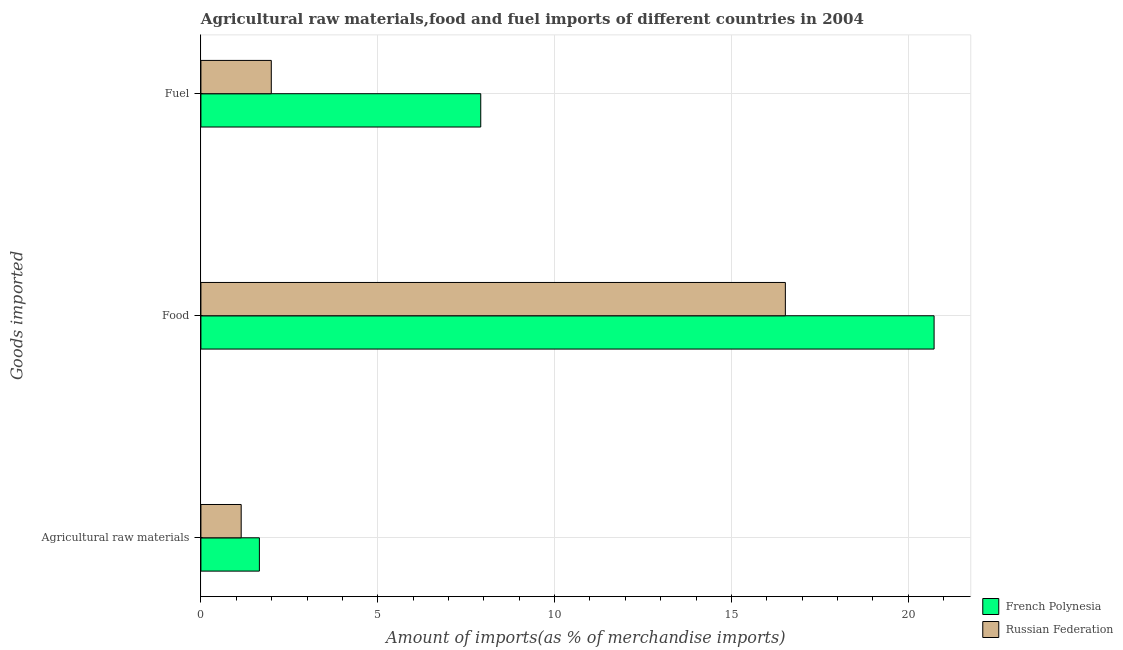How many groups of bars are there?
Provide a short and direct response. 3. Are the number of bars on each tick of the Y-axis equal?
Your response must be concise. Yes. How many bars are there on the 3rd tick from the top?
Provide a short and direct response. 2. What is the label of the 3rd group of bars from the top?
Your answer should be very brief. Agricultural raw materials. What is the percentage of fuel imports in French Polynesia?
Provide a short and direct response. 7.91. Across all countries, what is the maximum percentage of raw materials imports?
Offer a terse response. 1.65. Across all countries, what is the minimum percentage of fuel imports?
Your answer should be compact. 1.99. In which country was the percentage of food imports maximum?
Ensure brevity in your answer.  French Polynesia. In which country was the percentage of raw materials imports minimum?
Ensure brevity in your answer.  Russian Federation. What is the total percentage of food imports in the graph?
Give a very brief answer. 37.25. What is the difference between the percentage of fuel imports in French Polynesia and that in Russian Federation?
Make the answer very short. 5.92. What is the difference between the percentage of fuel imports in French Polynesia and the percentage of raw materials imports in Russian Federation?
Give a very brief answer. 6.77. What is the average percentage of food imports per country?
Your answer should be compact. 18.63. What is the difference between the percentage of food imports and percentage of fuel imports in French Polynesia?
Offer a very short reply. 12.82. What is the ratio of the percentage of food imports in French Polynesia to that in Russian Federation?
Keep it short and to the point. 1.25. Is the percentage of raw materials imports in Russian Federation less than that in French Polynesia?
Ensure brevity in your answer.  Yes. What is the difference between the highest and the second highest percentage of fuel imports?
Ensure brevity in your answer.  5.92. What is the difference between the highest and the lowest percentage of fuel imports?
Your response must be concise. 5.92. In how many countries, is the percentage of fuel imports greater than the average percentage of fuel imports taken over all countries?
Your response must be concise. 1. What does the 2nd bar from the top in Fuel represents?
Give a very brief answer. French Polynesia. What does the 1st bar from the bottom in Agricultural raw materials represents?
Provide a succinct answer. French Polynesia. Are all the bars in the graph horizontal?
Your answer should be very brief. Yes. How many countries are there in the graph?
Provide a succinct answer. 2. What is the difference between two consecutive major ticks on the X-axis?
Provide a short and direct response. 5. How are the legend labels stacked?
Ensure brevity in your answer.  Vertical. What is the title of the graph?
Ensure brevity in your answer.  Agricultural raw materials,food and fuel imports of different countries in 2004. Does "France" appear as one of the legend labels in the graph?
Provide a short and direct response. No. What is the label or title of the X-axis?
Your response must be concise. Amount of imports(as % of merchandise imports). What is the label or title of the Y-axis?
Provide a succinct answer. Goods imported. What is the Amount of imports(as % of merchandise imports) in French Polynesia in Agricultural raw materials?
Give a very brief answer. 1.65. What is the Amount of imports(as % of merchandise imports) of Russian Federation in Agricultural raw materials?
Provide a short and direct response. 1.14. What is the Amount of imports(as % of merchandise imports) in French Polynesia in Food?
Keep it short and to the point. 20.73. What is the Amount of imports(as % of merchandise imports) in Russian Federation in Food?
Make the answer very short. 16.52. What is the Amount of imports(as % of merchandise imports) in French Polynesia in Fuel?
Provide a short and direct response. 7.91. What is the Amount of imports(as % of merchandise imports) in Russian Federation in Fuel?
Your answer should be very brief. 1.99. Across all Goods imported, what is the maximum Amount of imports(as % of merchandise imports) of French Polynesia?
Keep it short and to the point. 20.73. Across all Goods imported, what is the maximum Amount of imports(as % of merchandise imports) of Russian Federation?
Your response must be concise. 16.52. Across all Goods imported, what is the minimum Amount of imports(as % of merchandise imports) in French Polynesia?
Offer a terse response. 1.65. Across all Goods imported, what is the minimum Amount of imports(as % of merchandise imports) of Russian Federation?
Make the answer very short. 1.14. What is the total Amount of imports(as % of merchandise imports) in French Polynesia in the graph?
Offer a very short reply. 30.29. What is the total Amount of imports(as % of merchandise imports) of Russian Federation in the graph?
Keep it short and to the point. 19.65. What is the difference between the Amount of imports(as % of merchandise imports) of French Polynesia in Agricultural raw materials and that in Food?
Your answer should be very brief. -19.08. What is the difference between the Amount of imports(as % of merchandise imports) of Russian Federation in Agricultural raw materials and that in Food?
Keep it short and to the point. -15.39. What is the difference between the Amount of imports(as % of merchandise imports) of French Polynesia in Agricultural raw materials and that in Fuel?
Provide a succinct answer. -6.26. What is the difference between the Amount of imports(as % of merchandise imports) in Russian Federation in Agricultural raw materials and that in Fuel?
Your answer should be compact. -0.85. What is the difference between the Amount of imports(as % of merchandise imports) of French Polynesia in Food and that in Fuel?
Offer a terse response. 12.82. What is the difference between the Amount of imports(as % of merchandise imports) of Russian Federation in Food and that in Fuel?
Your answer should be very brief. 14.53. What is the difference between the Amount of imports(as % of merchandise imports) of French Polynesia in Agricultural raw materials and the Amount of imports(as % of merchandise imports) of Russian Federation in Food?
Offer a terse response. -14.87. What is the difference between the Amount of imports(as % of merchandise imports) in French Polynesia in Agricultural raw materials and the Amount of imports(as % of merchandise imports) in Russian Federation in Fuel?
Make the answer very short. -0.34. What is the difference between the Amount of imports(as % of merchandise imports) of French Polynesia in Food and the Amount of imports(as % of merchandise imports) of Russian Federation in Fuel?
Offer a very short reply. 18.74. What is the average Amount of imports(as % of merchandise imports) in French Polynesia per Goods imported?
Provide a succinct answer. 10.1. What is the average Amount of imports(as % of merchandise imports) of Russian Federation per Goods imported?
Your answer should be very brief. 6.55. What is the difference between the Amount of imports(as % of merchandise imports) of French Polynesia and Amount of imports(as % of merchandise imports) of Russian Federation in Agricultural raw materials?
Your answer should be compact. 0.51. What is the difference between the Amount of imports(as % of merchandise imports) in French Polynesia and Amount of imports(as % of merchandise imports) in Russian Federation in Food?
Keep it short and to the point. 4.21. What is the difference between the Amount of imports(as % of merchandise imports) in French Polynesia and Amount of imports(as % of merchandise imports) in Russian Federation in Fuel?
Give a very brief answer. 5.92. What is the ratio of the Amount of imports(as % of merchandise imports) of French Polynesia in Agricultural raw materials to that in Food?
Give a very brief answer. 0.08. What is the ratio of the Amount of imports(as % of merchandise imports) in Russian Federation in Agricultural raw materials to that in Food?
Provide a short and direct response. 0.07. What is the ratio of the Amount of imports(as % of merchandise imports) in French Polynesia in Agricultural raw materials to that in Fuel?
Give a very brief answer. 0.21. What is the ratio of the Amount of imports(as % of merchandise imports) in Russian Federation in Agricultural raw materials to that in Fuel?
Provide a short and direct response. 0.57. What is the ratio of the Amount of imports(as % of merchandise imports) in French Polynesia in Food to that in Fuel?
Your answer should be compact. 2.62. What is the ratio of the Amount of imports(as % of merchandise imports) of Russian Federation in Food to that in Fuel?
Provide a succinct answer. 8.3. What is the difference between the highest and the second highest Amount of imports(as % of merchandise imports) in French Polynesia?
Provide a short and direct response. 12.82. What is the difference between the highest and the second highest Amount of imports(as % of merchandise imports) of Russian Federation?
Your answer should be very brief. 14.53. What is the difference between the highest and the lowest Amount of imports(as % of merchandise imports) in French Polynesia?
Your response must be concise. 19.08. What is the difference between the highest and the lowest Amount of imports(as % of merchandise imports) of Russian Federation?
Offer a terse response. 15.39. 